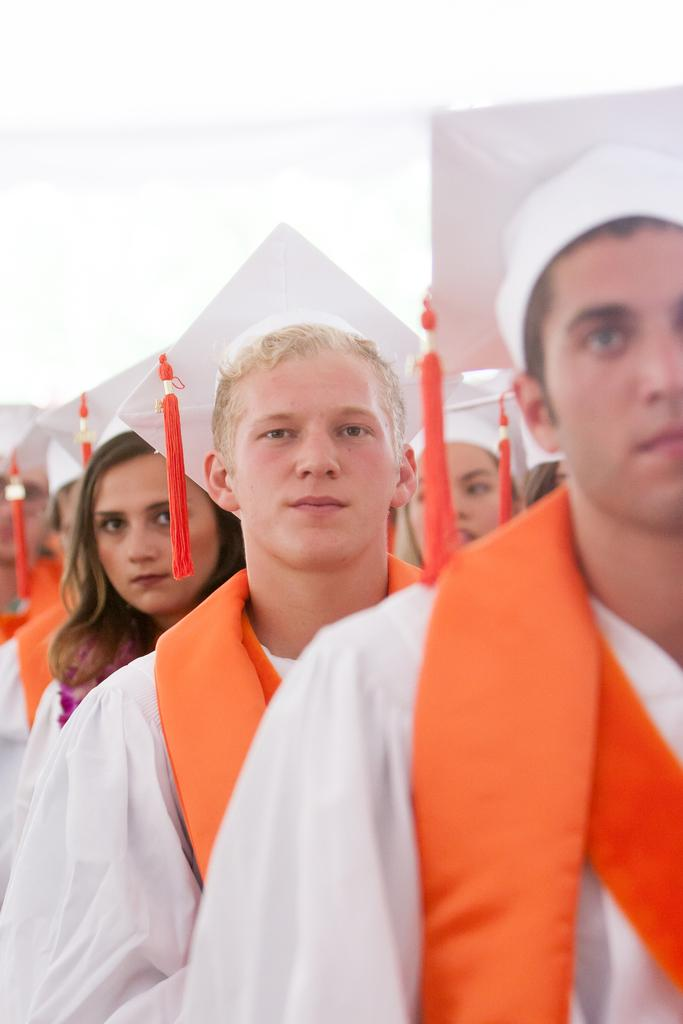How many individuals are present in the image? There are many people in the image. What is the color of the background in the image? The background of the image is white. What is the reason for the flight of the man in the image? There is no man or flight present in the image; it only features many people against a white background. 